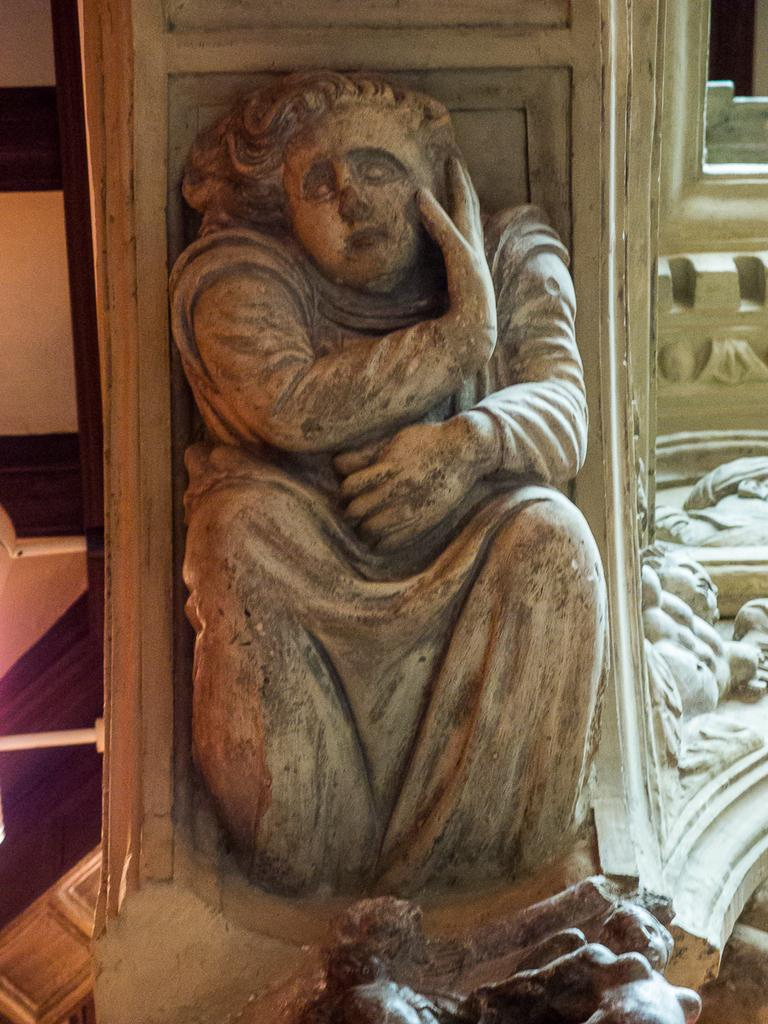What is the main subject in the center of the image? There is a statue in the center of the image. How many boats can be seen in the image? There are no boats present in the image; it features a statue. Can you describe the swimming technique of the person in the image? There is no person swimming in the image; it features a statue. 